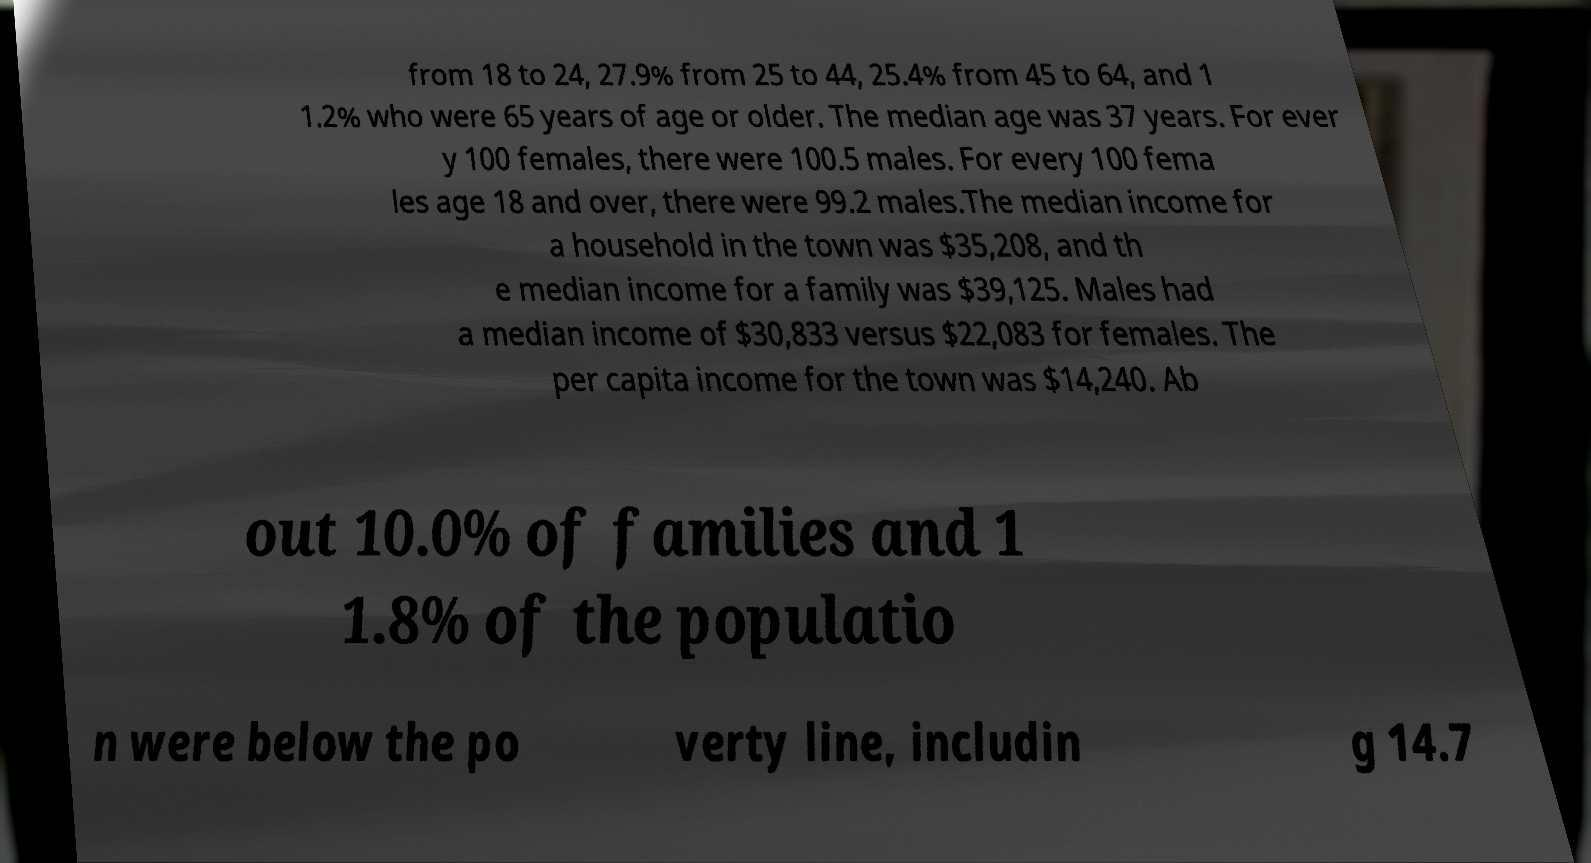There's text embedded in this image that I need extracted. Can you transcribe it verbatim? from 18 to 24, 27.9% from 25 to 44, 25.4% from 45 to 64, and 1 1.2% who were 65 years of age or older. The median age was 37 years. For ever y 100 females, there were 100.5 males. For every 100 fema les age 18 and over, there were 99.2 males.The median income for a household in the town was $35,208, and th e median income for a family was $39,125. Males had a median income of $30,833 versus $22,083 for females. The per capita income for the town was $14,240. Ab out 10.0% of families and 1 1.8% of the populatio n were below the po verty line, includin g 14.7 